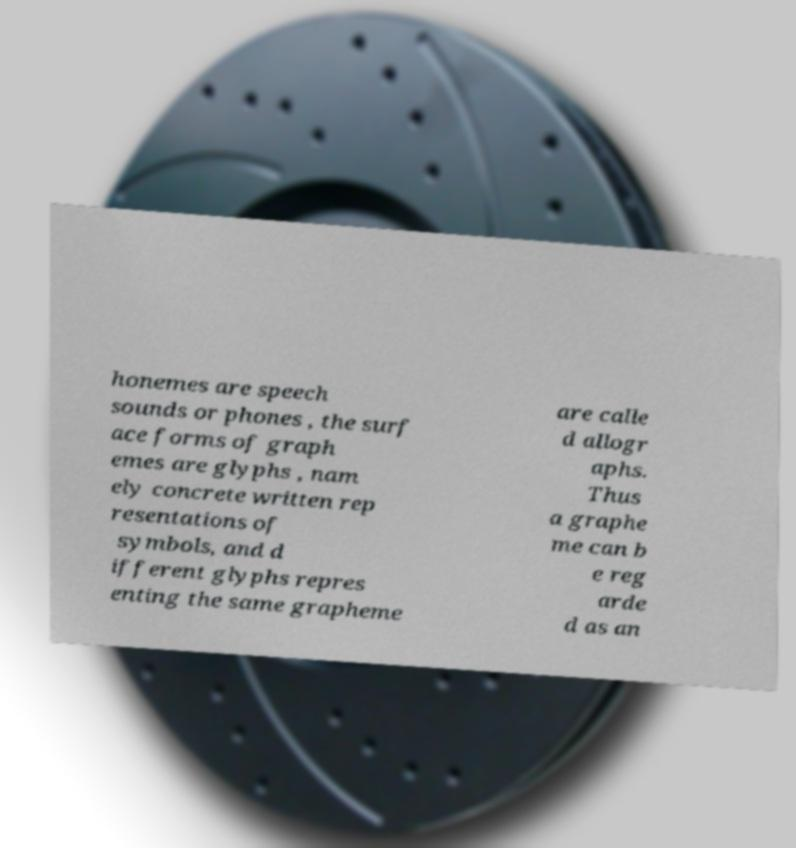For documentation purposes, I need the text within this image transcribed. Could you provide that? honemes are speech sounds or phones , the surf ace forms of graph emes are glyphs , nam ely concrete written rep resentations of symbols, and d ifferent glyphs repres enting the same grapheme are calle d allogr aphs. Thus a graphe me can b e reg arde d as an 